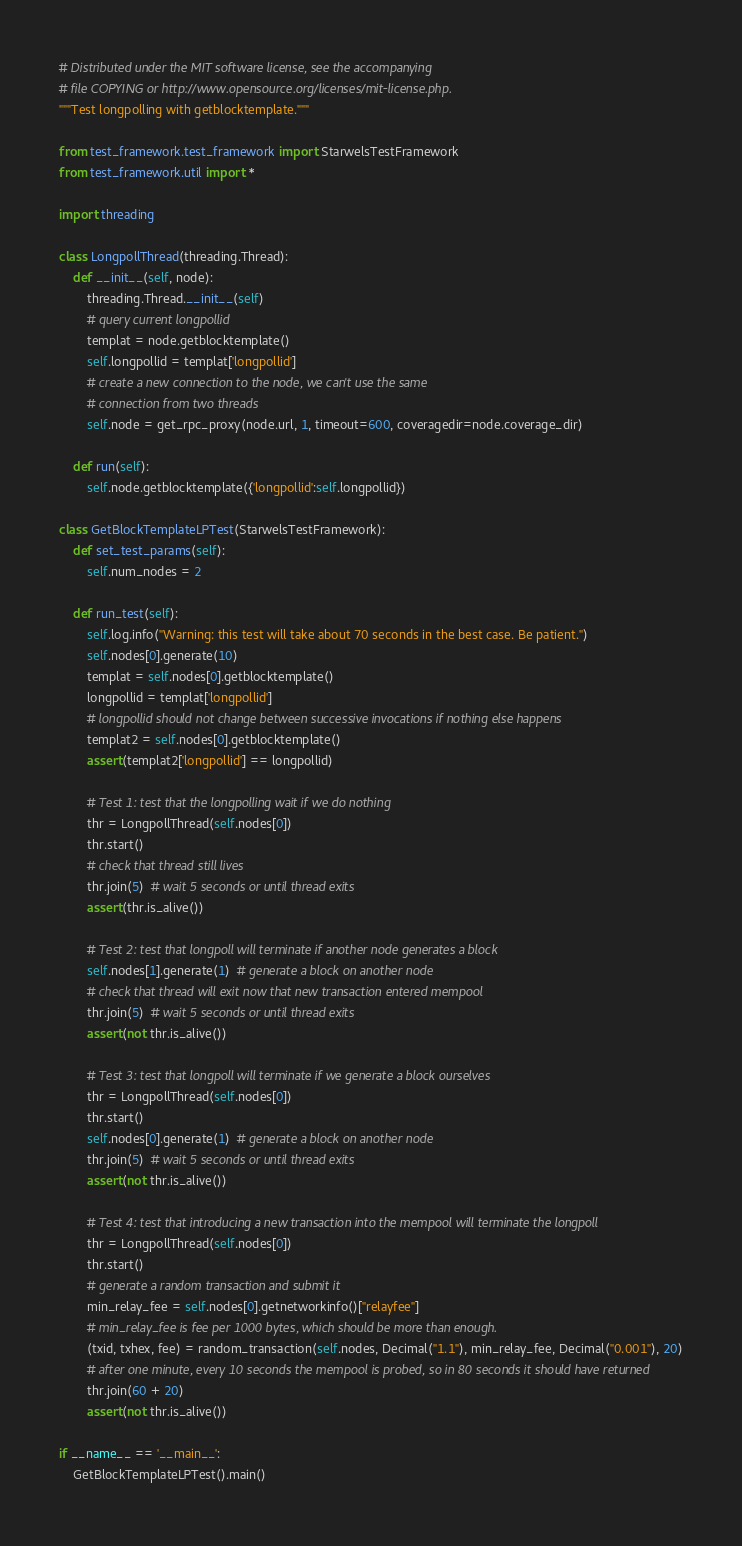Convert code to text. <code><loc_0><loc_0><loc_500><loc_500><_Python_># Distributed under the MIT software license, see the accompanying
# file COPYING or http://www.opensource.org/licenses/mit-license.php.
"""Test longpolling with getblocktemplate."""

from test_framework.test_framework import StarwelsTestFramework
from test_framework.util import *

import threading

class LongpollThread(threading.Thread):
    def __init__(self, node):
        threading.Thread.__init__(self)
        # query current longpollid
        templat = node.getblocktemplate()
        self.longpollid = templat['longpollid']
        # create a new connection to the node, we can't use the same
        # connection from two threads
        self.node = get_rpc_proxy(node.url, 1, timeout=600, coveragedir=node.coverage_dir)

    def run(self):
        self.node.getblocktemplate({'longpollid':self.longpollid})

class GetBlockTemplateLPTest(StarwelsTestFramework):
    def set_test_params(self):
        self.num_nodes = 2

    def run_test(self):
        self.log.info("Warning: this test will take about 70 seconds in the best case. Be patient.")
        self.nodes[0].generate(10)
        templat = self.nodes[0].getblocktemplate()
        longpollid = templat['longpollid']
        # longpollid should not change between successive invocations if nothing else happens
        templat2 = self.nodes[0].getblocktemplate()
        assert(templat2['longpollid'] == longpollid)

        # Test 1: test that the longpolling wait if we do nothing
        thr = LongpollThread(self.nodes[0])
        thr.start()
        # check that thread still lives
        thr.join(5)  # wait 5 seconds or until thread exits
        assert(thr.is_alive())

        # Test 2: test that longpoll will terminate if another node generates a block
        self.nodes[1].generate(1)  # generate a block on another node
        # check that thread will exit now that new transaction entered mempool
        thr.join(5)  # wait 5 seconds or until thread exits
        assert(not thr.is_alive())

        # Test 3: test that longpoll will terminate if we generate a block ourselves
        thr = LongpollThread(self.nodes[0])
        thr.start()
        self.nodes[0].generate(1)  # generate a block on another node
        thr.join(5)  # wait 5 seconds or until thread exits
        assert(not thr.is_alive())

        # Test 4: test that introducing a new transaction into the mempool will terminate the longpoll
        thr = LongpollThread(self.nodes[0])
        thr.start()
        # generate a random transaction and submit it
        min_relay_fee = self.nodes[0].getnetworkinfo()["relayfee"]
        # min_relay_fee is fee per 1000 bytes, which should be more than enough.
        (txid, txhex, fee) = random_transaction(self.nodes, Decimal("1.1"), min_relay_fee, Decimal("0.001"), 20)
        # after one minute, every 10 seconds the mempool is probed, so in 80 seconds it should have returned
        thr.join(60 + 20)
        assert(not thr.is_alive())

if __name__ == '__main__':
    GetBlockTemplateLPTest().main()

</code> 